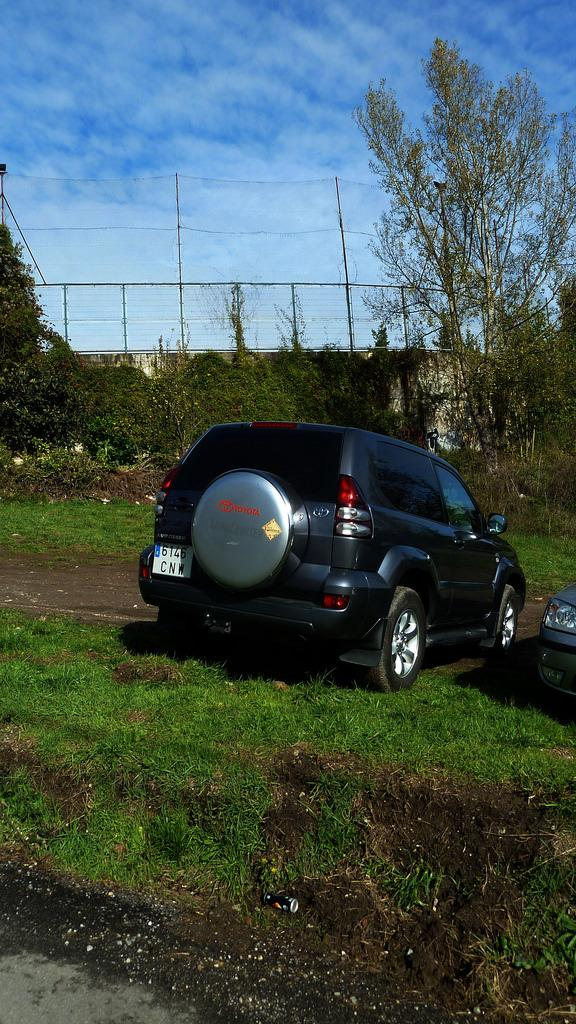What is the main subject in the center of the image? There is a car in the center of the image. What type of terrain is visible at the bottom of the image? There is grass at the bottom of the image. What structures can be seen in the background of the image? There is a fence, a net, and poles in the background of the image. What type of vegetation is visible in the background of the image? There are trees in the background of the image. What is visible at the top of the image? The sky is visible at the top of the image. What type of rock is being carried by the laborer in the image? There is no laborer or rock present in the image. What is the car doing in the back of the image? The car is not in the back of the image; it is in the center of the image. 